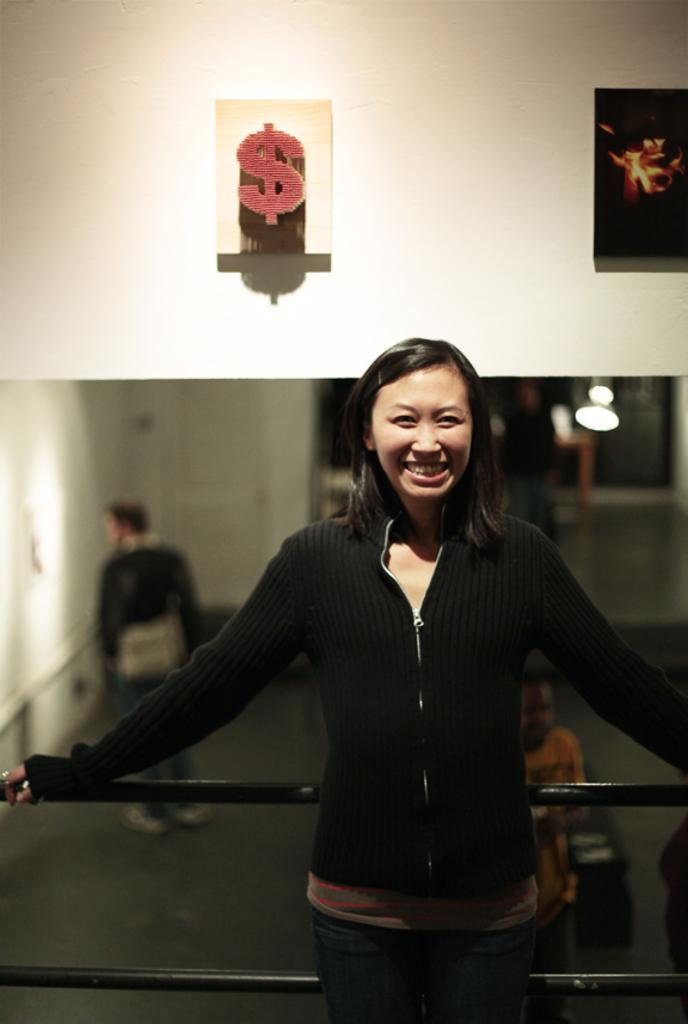What is the main subject of the image? There is a beautiful woman standing in the middle of the image. What is the woman wearing? The woman is wearing a black color sweater. What is the woman's facial expression? The woman is smiling. What can be seen on the wall in the image? There is a dollar symbol on the wall in the image. What type of corn is being cooked in the steam in the image? There is no corn or steam present in the image; it features a woman standing in front of a wall with a dollar symbol. 